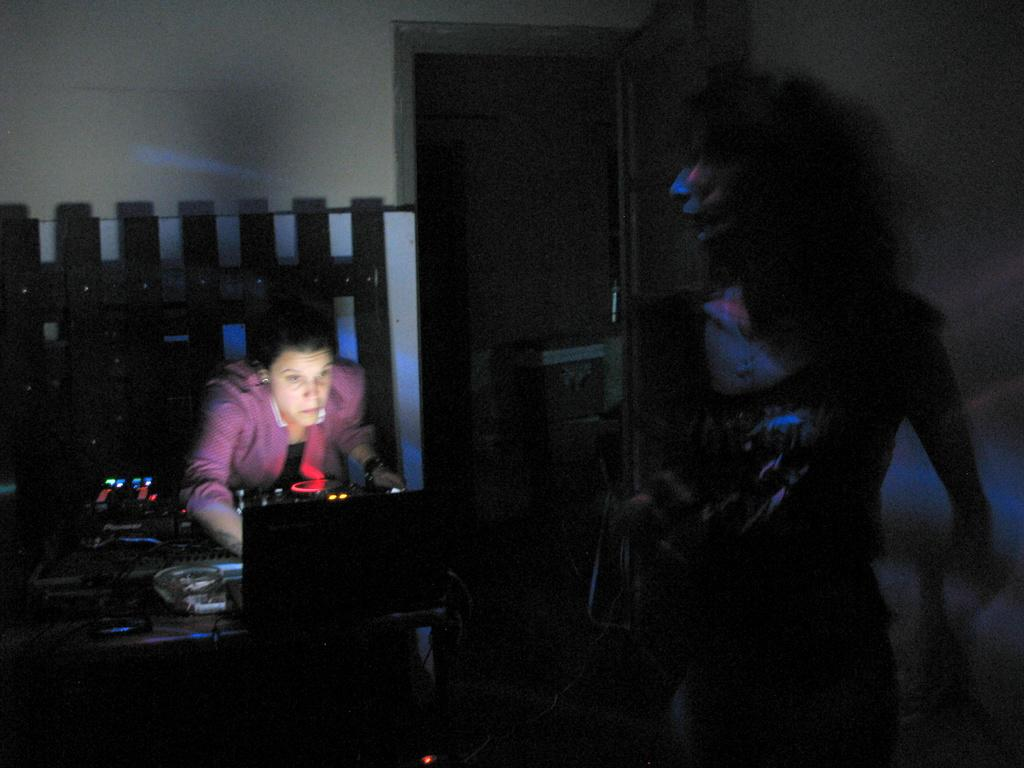How many people are in the image? There are two people in the image. What is present in the image besides the people? There is a table, musical instruments, a laptop, and a wall in the background of the image. What is on the table in the image? There are musical instruments and a laptop on the table. What can be seen in the background of the image? There is a wall in the background of the image. How many lizards are crawling on the wall in the image? There are no lizards present in the image; only the two people, table, musical instruments, laptop, and wall are visible. 